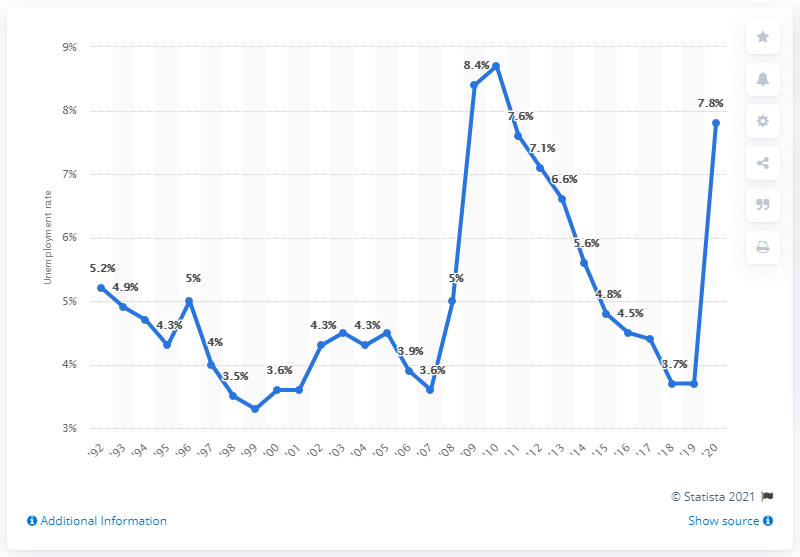Identify some key points in this picture. In 2020, the unemployment rate in Delaware was 7.8%. In 2010, Delaware's highest unemployment rate was 8.7%. In 2010, the unemployment rate in Delaware was 3.7%. 